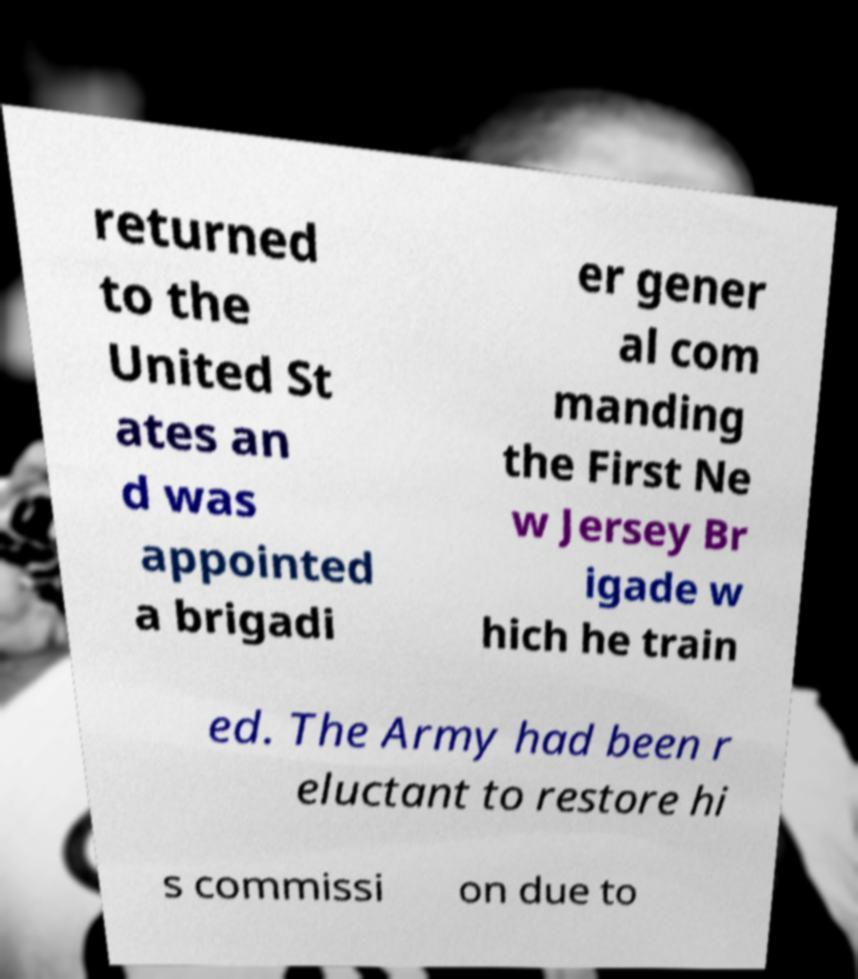Could you extract and type out the text from this image? returned to the United St ates an d was appointed a brigadi er gener al com manding the First Ne w Jersey Br igade w hich he train ed. The Army had been r eluctant to restore hi s commissi on due to 